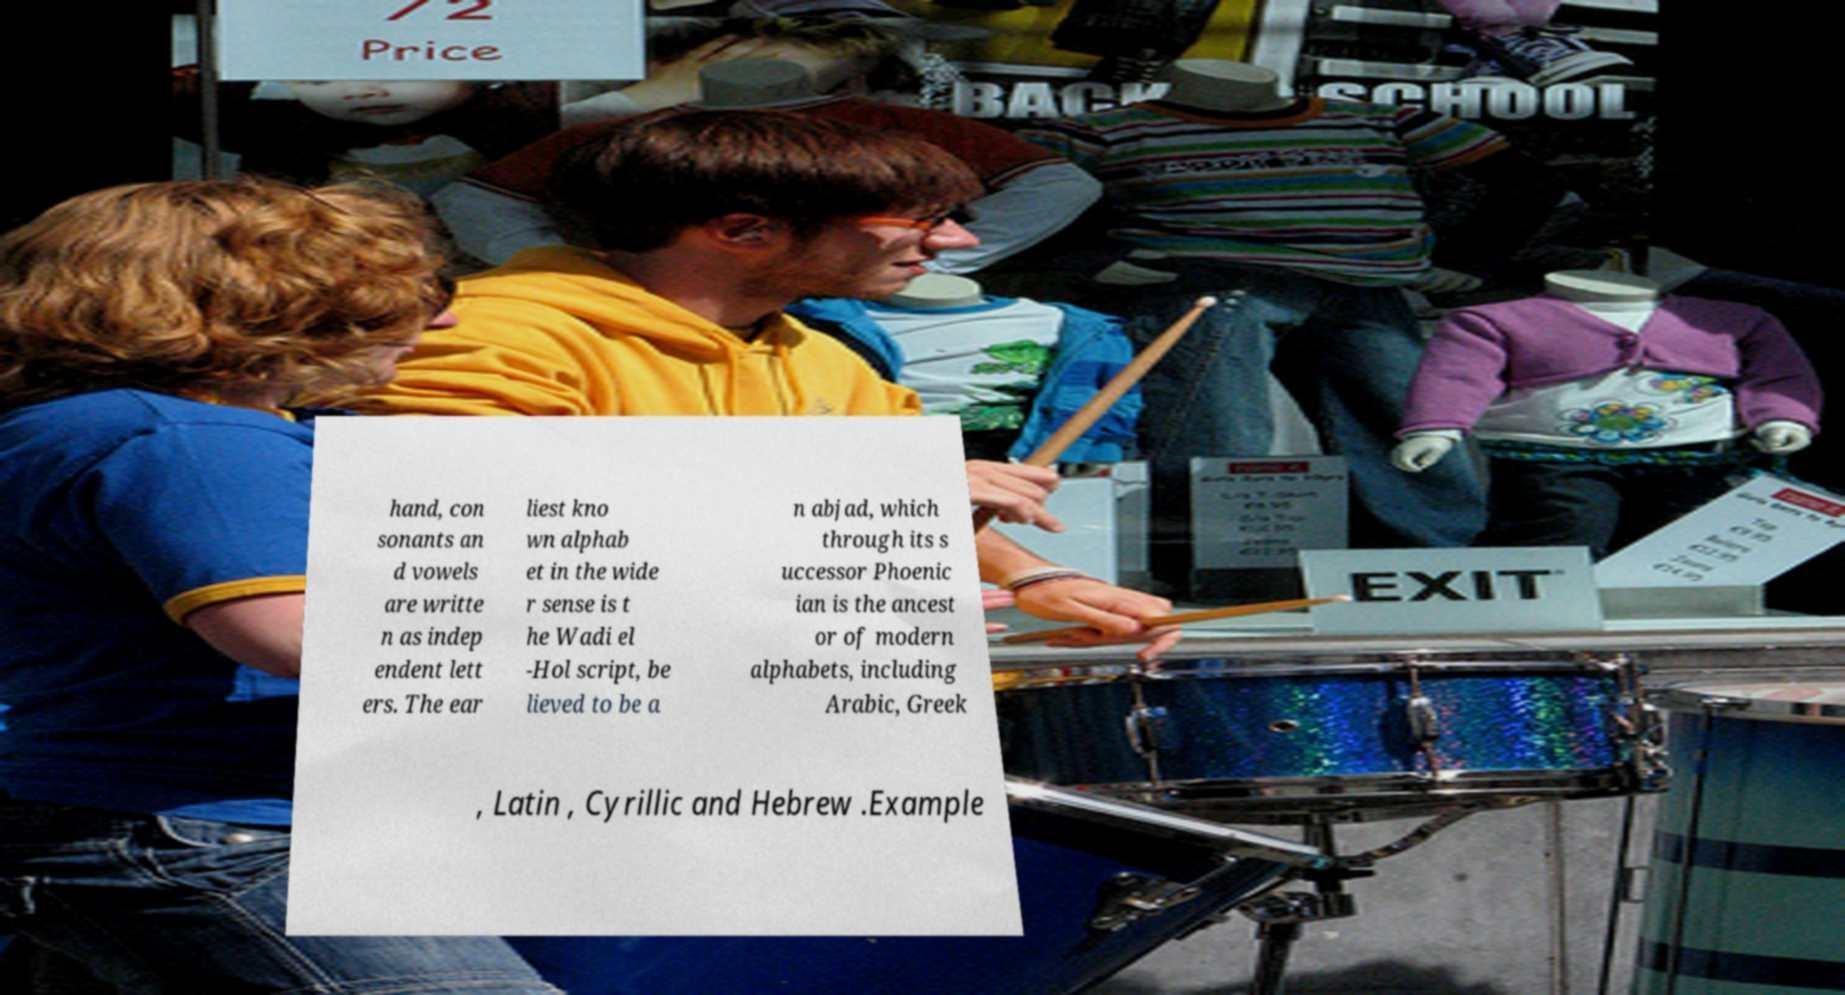What messages or text are displayed in this image? I need them in a readable, typed format. hand, con sonants an d vowels are writte n as indep endent lett ers. The ear liest kno wn alphab et in the wide r sense is t he Wadi el -Hol script, be lieved to be a n abjad, which through its s uccessor Phoenic ian is the ancest or of modern alphabets, including Arabic, Greek , Latin , Cyrillic and Hebrew .Example 